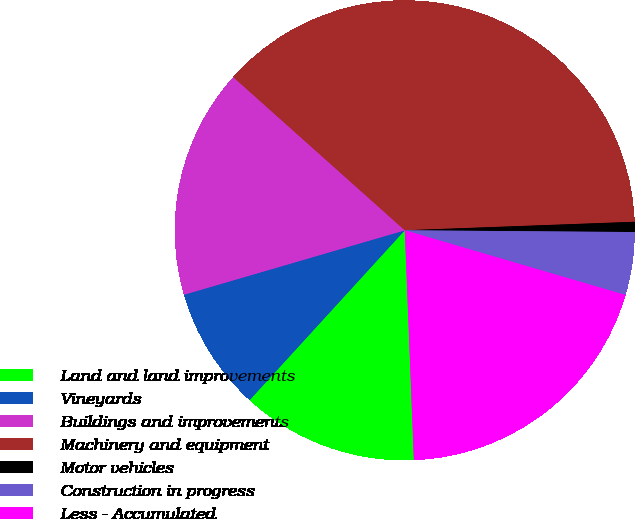<chart> <loc_0><loc_0><loc_500><loc_500><pie_chart><fcel>Land and land improvements<fcel>Vineyards<fcel>Buildings and improvements<fcel>Machinery and equipment<fcel>Motor vehicles<fcel>Construction in progress<fcel>Less - Accumulated<nl><fcel>12.41%<fcel>8.7%<fcel>16.12%<fcel>37.81%<fcel>0.71%<fcel>4.42%<fcel>19.83%<nl></chart> 